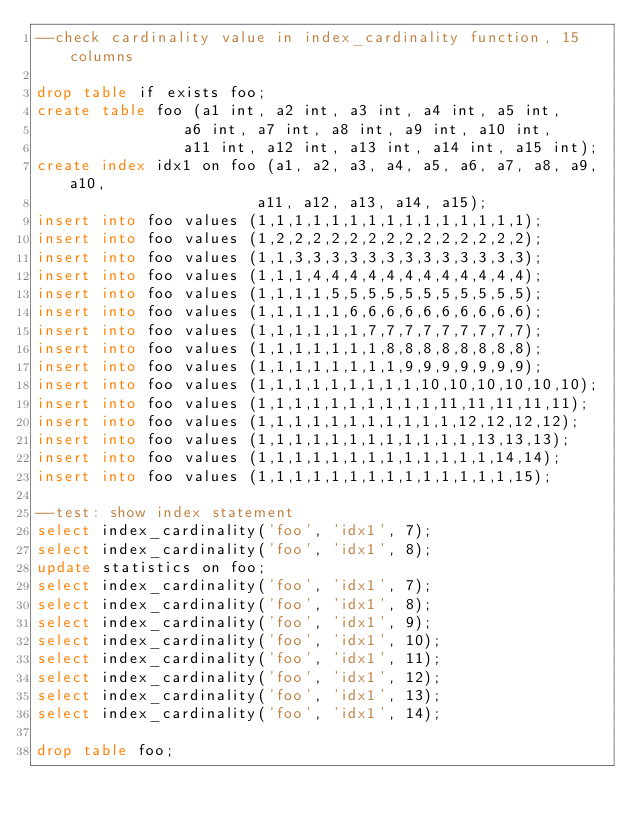<code> <loc_0><loc_0><loc_500><loc_500><_SQL_>--check cardinality value in index_cardinality function, 15 columns

drop table if exists foo;
create table foo (a1 int, a2 int, a3 int, a4 int, a5 int,
                a6 int, a7 int, a8 int, a9 int, a10 int,
                a11 int, a12 int, a13 int, a14 int, a15 int);
create index idx1 on foo (a1, a2, a3, a4, a5, a6, a7, a8, a9, a10,
                        a11, a12, a13, a14, a15);
insert into foo values (1,1,1,1,1,1,1,1,1,1,1,1,1,1,1);
insert into foo values (1,2,2,2,2,2,2,2,2,2,2,2,2,2,2);
insert into foo values (1,1,3,3,3,3,3,3,3,3,3,3,3,3,3);
insert into foo values (1,1,1,4,4,4,4,4,4,4,4,4,4,4,4);
insert into foo values (1,1,1,1,5,5,5,5,5,5,5,5,5,5,5);
insert into foo values (1,1,1,1,1,6,6,6,6,6,6,6,6,6,6);
insert into foo values (1,1,1,1,1,1,7,7,7,7,7,7,7,7,7);
insert into foo values (1,1,1,1,1,1,1,8,8,8,8,8,8,8,8);
insert into foo values (1,1,1,1,1,1,1,1,9,9,9,9,9,9,9);
insert into foo values (1,1,1,1,1,1,1,1,1,10,10,10,10,10,10);
insert into foo values (1,1,1,1,1,1,1,1,1,1,11,11,11,11,11);
insert into foo values (1,1,1,1,1,1,1,1,1,1,1,12,12,12,12);
insert into foo values (1,1,1,1,1,1,1,1,1,1,1,1,13,13,13);
insert into foo values (1,1,1,1,1,1,1,1,1,1,1,1,1,14,14);
insert into foo values (1,1,1,1,1,1,1,1,1,1,1,1,1,1,15);

--test: show index statement
select index_cardinality('foo', 'idx1', 7);
select index_cardinality('foo', 'idx1', 8);
update statistics on foo;
select index_cardinality('foo', 'idx1', 7);
select index_cardinality('foo', 'idx1', 8);
select index_cardinality('foo', 'idx1', 9);
select index_cardinality('foo', 'idx1', 10);
select index_cardinality('foo', 'idx1', 11);
select index_cardinality('foo', 'idx1', 12);
select index_cardinality('foo', 'idx1', 13);
select index_cardinality('foo', 'idx1', 14);

drop table foo;


</code> 